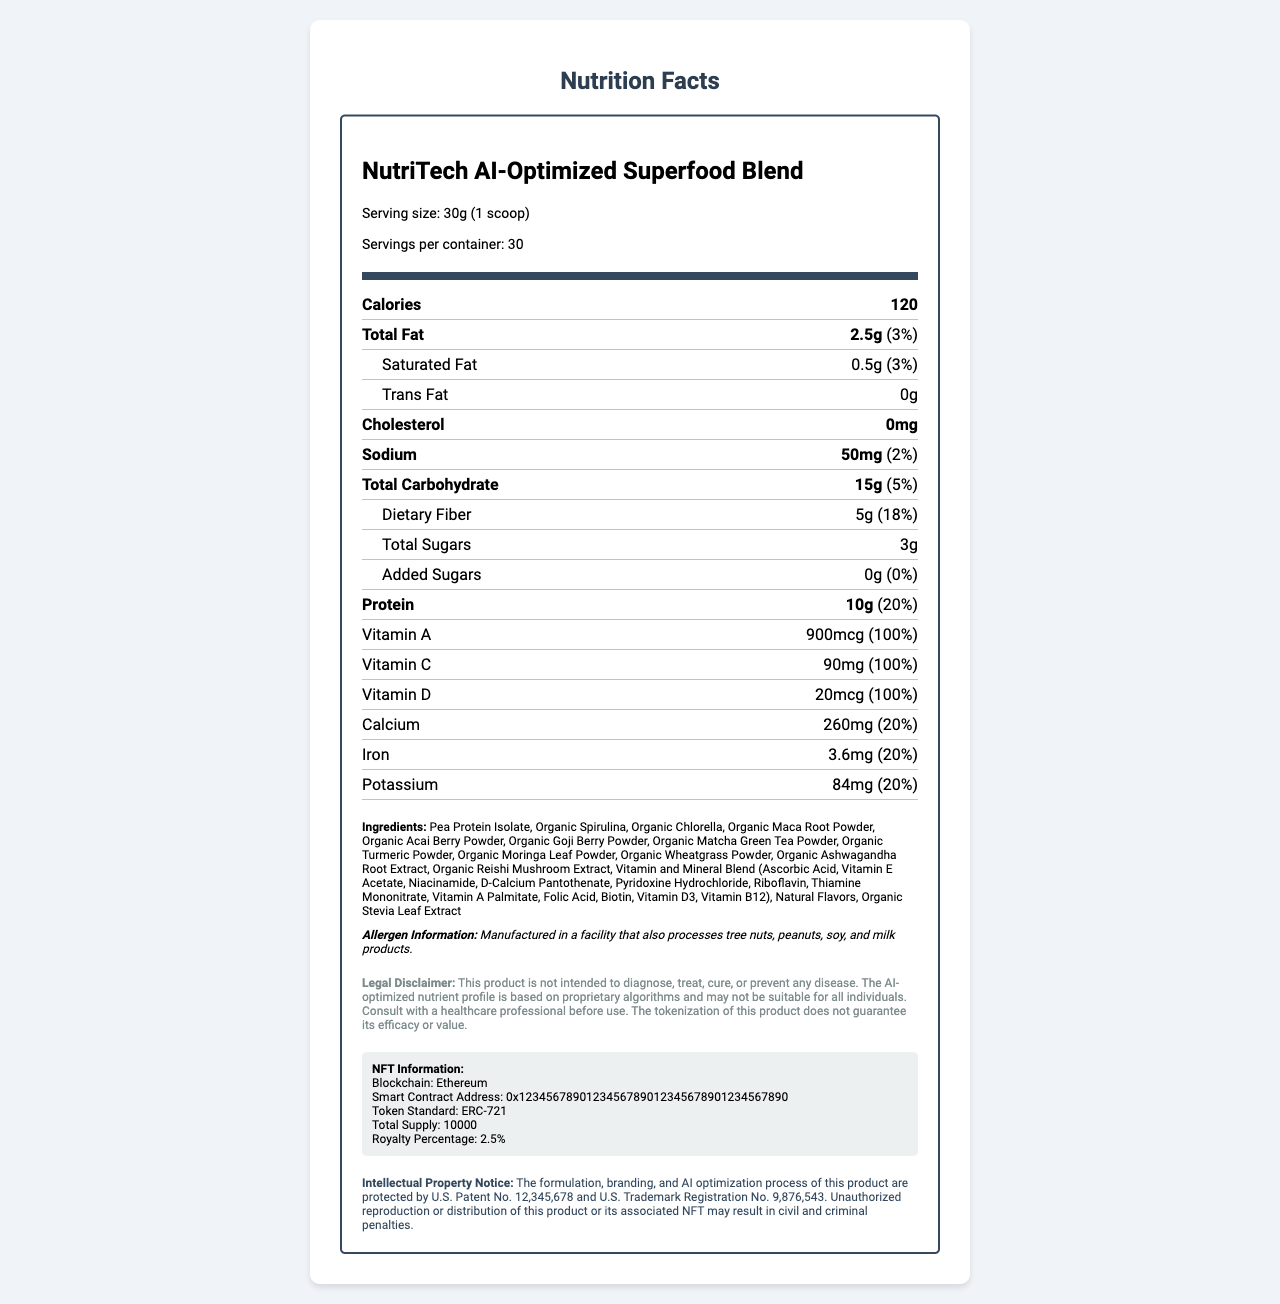what is the serving size? The serving size is explicitly stated as "30g (1 scoop)" in the document.
Answer: 30g (1 scoop) how many servings are there per container? The document clearly mentions that there are 30 servings per container.
Answer: 30 how many calories are in a serving? The number of calories per serving is stated as 120.
Answer: 120 what is the amount of saturated fat per serving? The amount of saturated fat per serving is listed as 0.5g.
Answer: 0.5g what is the total fat percentage of daily value? The daily value percentage for total fat is noted as 3%.
Answer: 3% which vitamins are present in 100% daily value? A. Vitamin B12 B. Vitamin D C. Vitamin K D. All of the above The document lists multiple vitamins (including Vitamin B12, Vitamin D, and Vitamin K) at 100% daily value each.
Answer: D. All of the above how much protein does each serving contain? Each serving contains 10g of protein as indicated.
Answer: 10g what allergens are processed in the same facility? The allergen information states the facility processes tree nuts, peanuts, soy, and milk products.
Answer: Tree nuts, peanuts, soy, and milk products what is the smart contract address for this product's NFT? The document specifies the smart contract address under the NFT information section.
Answer: 0x1234567890123456789012345678901234567890 how much dietary fiber is in each serving? The dietary fiber per serving is listed as 5g.
Answer: 5g are there any added sugars in the product? The document indicates that the amount of added sugars is 0g.
Answer: No is this product suitable to diagnose, treat, cure, or prevent any disease? The legal disclaimer clearly states that the product is not intended to diagnose, treat, cure, or prevent any disease.
Answer: No summarize the main idea of the document. The document provides detailed nutritional information for NutriTech AI-Optimized Superfood Blend, including serving size, calories, and daily value percentages for various nutrients. It lists the ingredients, allergen information, a legal disclaimer, and details regarding the product's associated NFT and intellectual property notices.
Answer: Summary of NutriTech AI-Optimized Superfood Blend how much is the royalty percentage for the NFT? The NFT information specifies a royalty percentage of 2.5%.
Answer: 2.5% what is the vitamin A daily value percentage? The vitamin A daily value percentage is stated as 100%.
Answer: 100% which of the following ingredients is not listed? A. Organic Spirulina B. Organic Wheatgrass Powder C. Blueberries D. Organic Matcha Green Tea Powder The ingredients list does not include blueberries, but it includes Organic Spirulina, Organic Wheatgrass Powder, and Organic Matcha Green Tea Powder.
Answer: C. Blueberries what are the blockchain and token standard for the NFT? The NFT information specifies that it is on the Ethereum blockchain and follows the ERC-721 token standard.
Answer: Ethereum, ERC-721 is the formulation, branding, and AI optimization process protected by intellectual property rights? The document mentions that these aspects are protected under U.S. patent and trademark registrations.
Answer: Yes who should be consulted before using the product? The legal disclaimer advises consulting with a healthcare professional before use.
Answer: Healthcare professional does the document detail the proprietary AI algorithms used? The document does not provide specific details about the proprietary AI algorithms used for optimization.
Answer: I don't know 